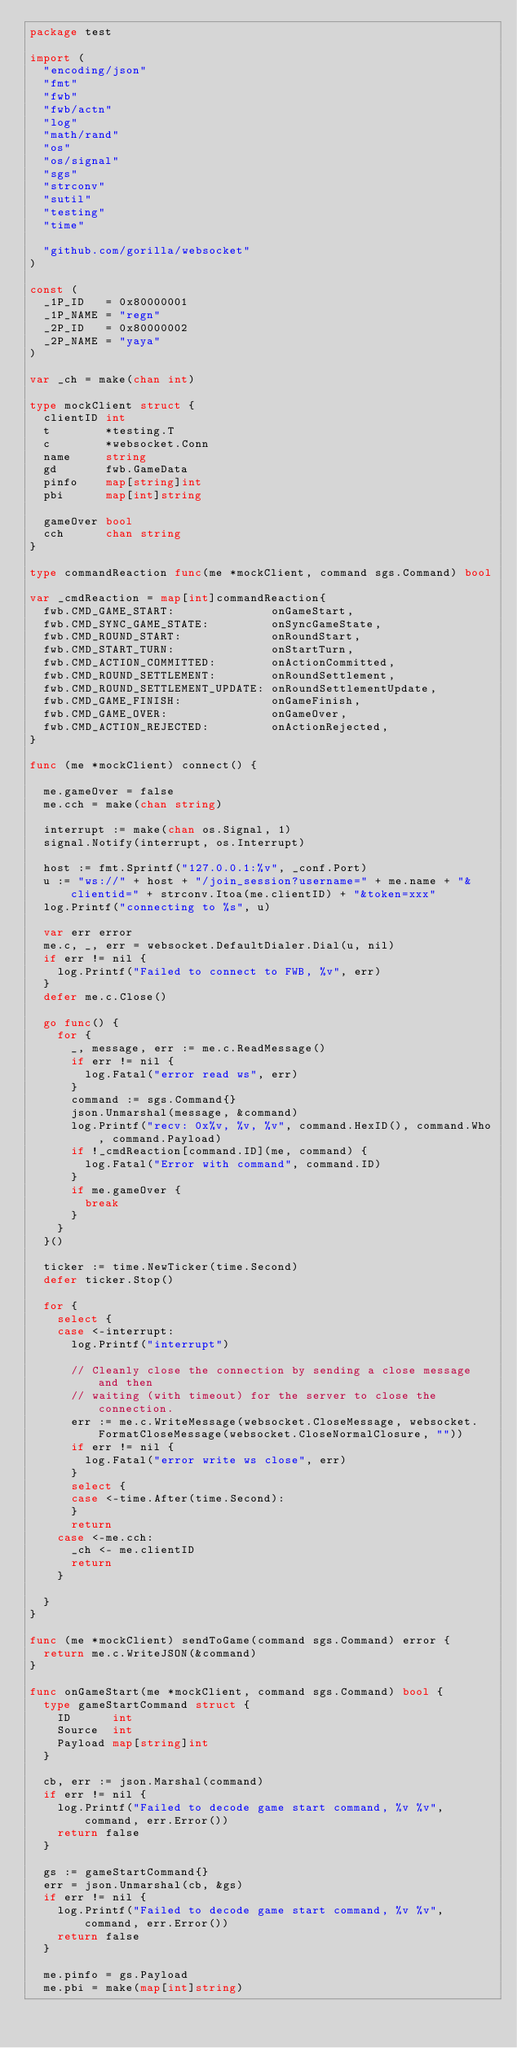Convert code to text. <code><loc_0><loc_0><loc_500><loc_500><_Go_>package test

import (
	"encoding/json"
	"fmt"
	"fwb"
	"fwb/actn"
	"log"
	"math/rand"
	"os"
	"os/signal"
	"sgs"
	"strconv"
	"sutil"
	"testing"
	"time"

	"github.com/gorilla/websocket"
)

const (
	_1P_ID   = 0x80000001
	_1P_NAME = "regn"
	_2P_ID   = 0x80000002
	_2P_NAME = "yaya"
)

var _ch = make(chan int)

type mockClient struct {
	clientID int
	t        *testing.T
	c        *websocket.Conn
	name     string
	gd       fwb.GameData
	pinfo    map[string]int
	pbi      map[int]string

	gameOver bool
	cch      chan string
}

type commandReaction func(me *mockClient, command sgs.Command) bool

var _cmdReaction = map[int]commandReaction{
	fwb.CMD_GAME_START:              onGameStart,
	fwb.CMD_SYNC_GAME_STATE:         onSyncGameState,
	fwb.CMD_ROUND_START:             onRoundStart,
	fwb.CMD_START_TURN:              onStartTurn,
	fwb.CMD_ACTION_COMMITTED:        onActionCommitted,
	fwb.CMD_ROUND_SETTLEMENT:        onRoundSettlement,
	fwb.CMD_ROUND_SETTLEMENT_UPDATE: onRoundSettlementUpdate,
	fwb.CMD_GAME_FINISH:             onGameFinish,
	fwb.CMD_GAME_OVER:               onGameOver,
	fwb.CMD_ACTION_REJECTED:         onActionRejected,
}

func (me *mockClient) connect() {

	me.gameOver = false
	me.cch = make(chan string)

	interrupt := make(chan os.Signal, 1)
	signal.Notify(interrupt, os.Interrupt)

	host := fmt.Sprintf("127.0.0.1:%v", _conf.Port)
	u := "ws://" + host + "/join_session?username=" + me.name + "&clientid=" + strconv.Itoa(me.clientID) + "&token=xxx"
	log.Printf("connecting to %s", u)

	var err error
	me.c, _, err = websocket.DefaultDialer.Dial(u, nil)
	if err != nil {
		log.Printf("Failed to connect to FWB, %v", err)
	}
	defer me.c.Close()

	go func() {
		for {
			_, message, err := me.c.ReadMessage()
			if err != nil {
				log.Fatal("error read ws", err)
			}
			command := sgs.Command{}
			json.Unmarshal(message, &command)
			log.Printf("recv: 0x%v, %v, %v", command.HexID(), command.Who, command.Payload)
			if !_cmdReaction[command.ID](me, command) {
				log.Fatal("Error with command", command.ID)
			}
			if me.gameOver {
				break
			}
		}
	}()

	ticker := time.NewTicker(time.Second)
	defer ticker.Stop()

	for {
		select {
		case <-interrupt:
			log.Printf("interrupt")

			// Cleanly close the connection by sending a close message and then
			// waiting (with timeout) for the server to close the connection.
			err := me.c.WriteMessage(websocket.CloseMessage, websocket.FormatCloseMessage(websocket.CloseNormalClosure, ""))
			if err != nil {
				log.Fatal("error write ws close", err)
			}
			select {
			case <-time.After(time.Second):
			}
			return
		case <-me.cch:
			_ch <- me.clientID
			return
		}

	}
}

func (me *mockClient) sendToGame(command sgs.Command) error {
	return me.c.WriteJSON(&command)
}

func onGameStart(me *mockClient, command sgs.Command) bool {
	type gameStartCommand struct {
		ID      int
		Source  int
		Payload map[string]int
	}

	cb, err := json.Marshal(command)
	if err != nil {
		log.Printf("Failed to decode game start command, %v %v", command, err.Error())
		return false
	}

	gs := gameStartCommand{}
	err = json.Unmarshal(cb, &gs)
	if err != nil {
		log.Printf("Failed to decode game start command, %v %v", command, err.Error())
		return false
	}

	me.pinfo = gs.Payload
	me.pbi = make(map[int]string)</code> 